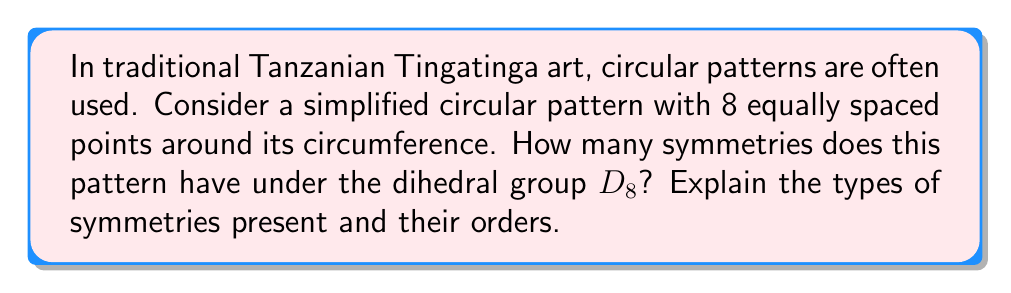Give your solution to this math problem. To analyze the symmetries of this Tanzanian-inspired pattern using group theory, we need to consider the dihedral group $D_8$, which describes the symmetries of a regular octagon.

1) The symmetries in $D_8$ consist of rotations and reflections:

   a) Rotations: There are 8 rotational symmetries, including the identity.
      - Identity (0° rotation)
      - Rotations by 45°, 90°, 135°, 180°, 225°, 270°, and 315°

   b) Reflections: There are 8 reflection symmetries.
      - 4 reflections across lines through opposite vertices
      - 4 reflections across lines through the midpoints of opposite sides

2) To calculate the total number of symmetries, we add the number of rotations and reflections:
   
   $$\text{Total symmetries} = \text{Rotations} + \text{Reflections} = 8 + 8 = 16$$

3) The orders of these symmetries are as follows:

   - The identity element has order 1
   - The 45°, 135°, 225°, and 315° rotations have order 8
   - The 90° and 270° rotations have order 4
   - The 180° rotation has order 2
   - All reflections have order 2

4) The group structure of $D_8$ can be described by the presentation:

   $$D_8 = \langle r, s \mid r^8 = s^2 = 1, srs = r^{-1} \rangle$$

   where $r$ represents a 45° rotation and $s$ represents a reflection.

This analysis demonstrates how group theory can be applied to understand the mathematical structure underlying traditional Tanzanian art patterns, providing a connection between mathematics and cultural aesthetics.
Answer: The circular pattern with 8 equally spaced points has 16 symmetries under the dihedral group $D_8$. These consist of 8 rotational symmetries (including the identity) and 8 reflection symmetries. 